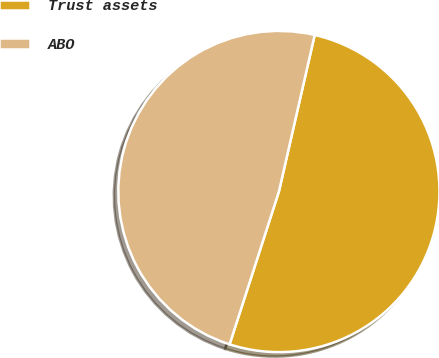Convert chart to OTSL. <chart><loc_0><loc_0><loc_500><loc_500><pie_chart><fcel>Trust assets<fcel>ABO<nl><fcel>51.39%<fcel>48.61%<nl></chart> 